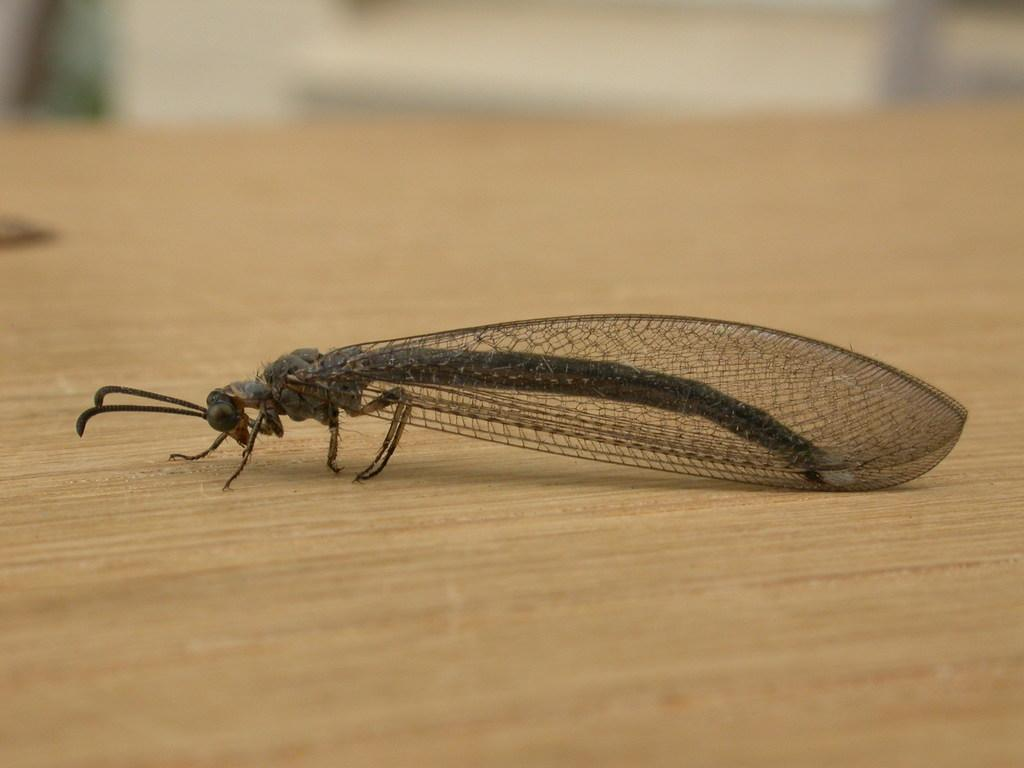What type of creature is in the image? There is an insect in the image. What are the main features of the insect? The insect has wings and legs. What surface is the insect on? The insect is on a wooden surface. How would you describe the background of the image? The background of the image is blurred. What is the insect doing with its mouth in the image? There is no indication of the insect using its mouth in the image. 